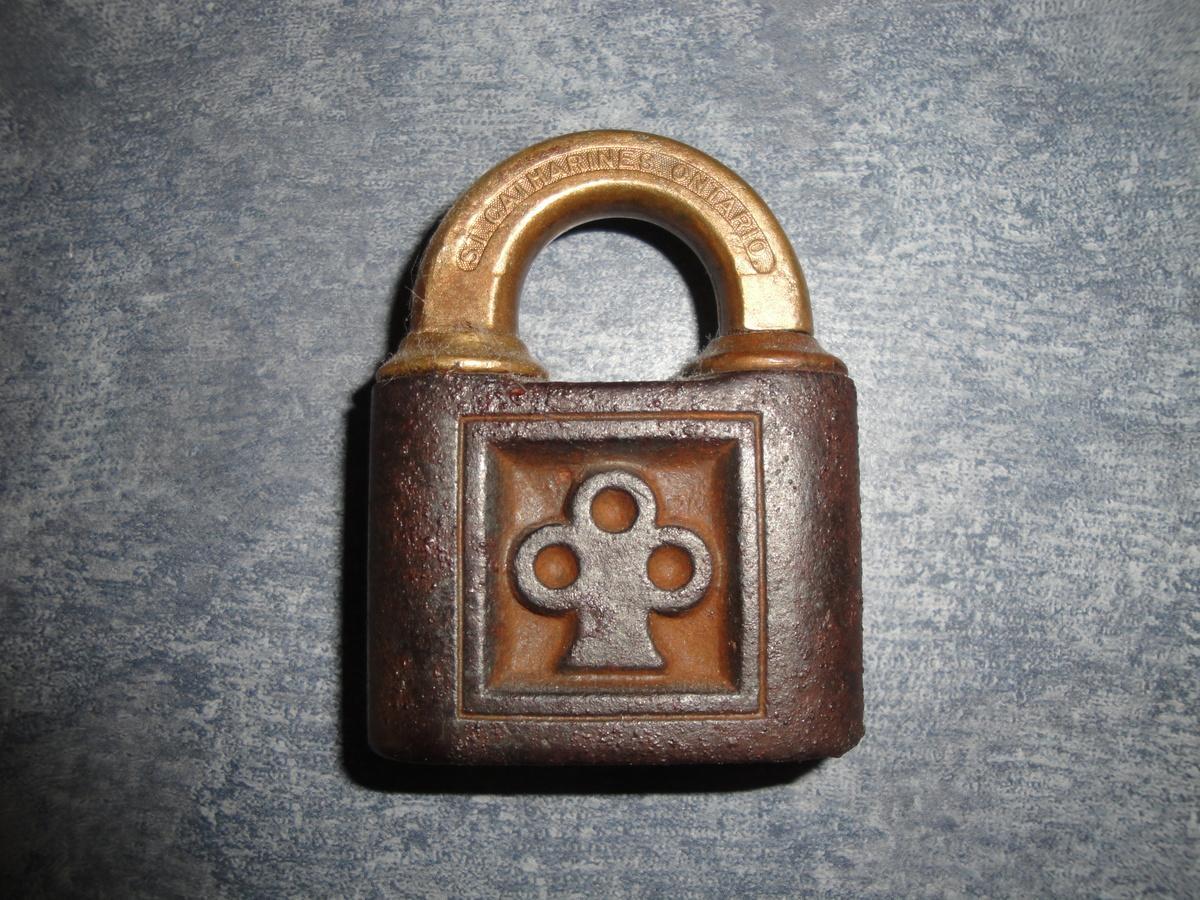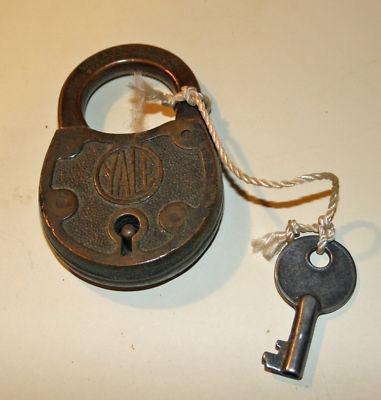The first image is the image on the left, the second image is the image on the right. For the images displayed, is the sentence "An image shows three locks of similar style and includes some keys." factually correct? Answer yes or no. No. The first image is the image on the left, the second image is the image on the right. Evaluate the accuracy of this statement regarding the images: "There are four closed and locked padlocks in total.". Is it true? Answer yes or no. No. 